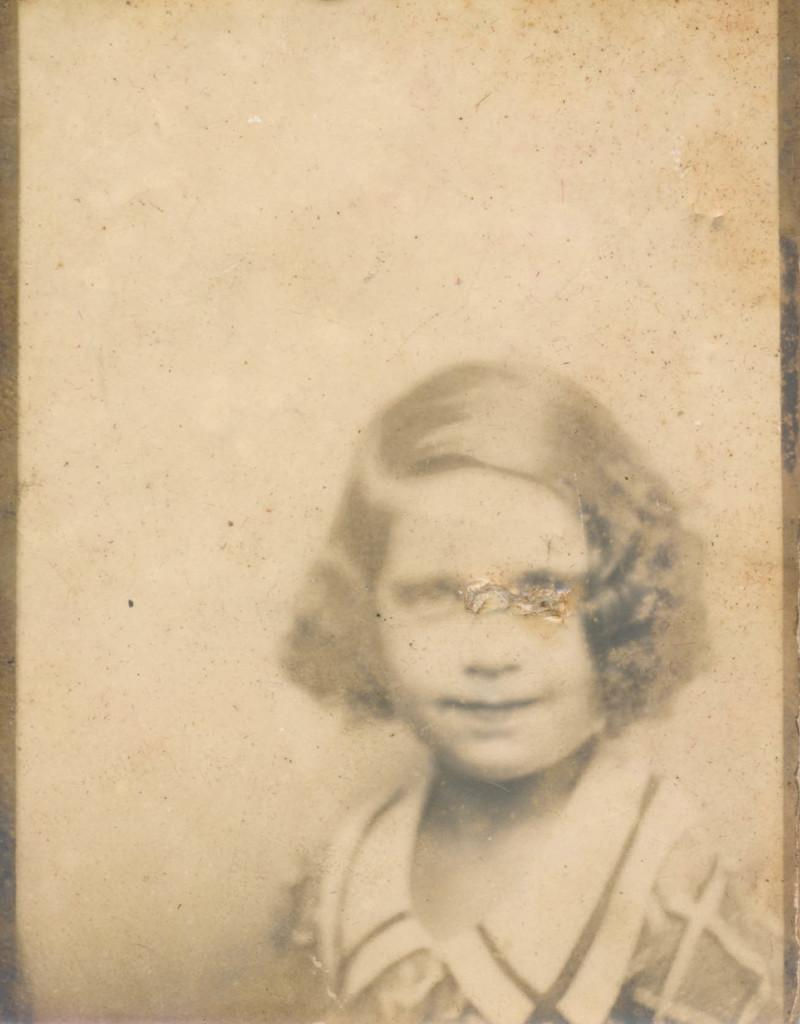What type of picture is in the image? The image contains a black and white picture. What is the subject of the picture? The picture is of a girl. What educational process is the girl undergoing in the image? There is no indication of any educational process in the image; it only shows a picture of a girl. Can the girl in the picture be seen canning fruits in the image? There is no canning activity or any fruits visible in the image. 